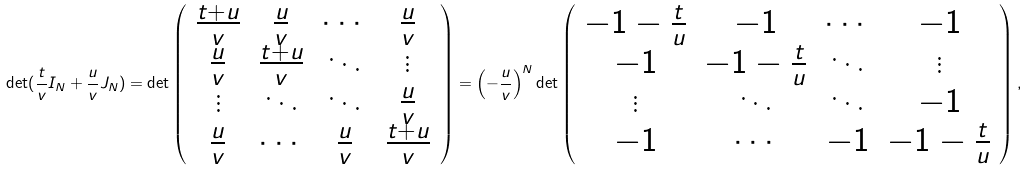Convert formula to latex. <formula><loc_0><loc_0><loc_500><loc_500>\det ( \frac { t } { v } { I } _ { N } + \frac { u } { v } { J } _ { N } ) = \det \left ( \begin{array} { c c c c } \frac { t + u } { v } & \frac { u } { v } & \cdots & \frac { u } { v } \\ \frac { u } { v } & \frac { t + u } { v } & \ddots & \vdots \\ \vdots & \ddots & \ddots & \frac { u } { v } \\ \frac { u } { v } & \cdots & \frac { u } { v } & \frac { t + u } { v } \\ \end{array} \right ) = \left ( - \frac { u } { v } \right ) ^ { N } \det \left ( \begin{array} { c c c c } - 1 - \frac { t } { u } & - 1 & \cdots & - 1 \\ - 1 & - 1 - \frac { t } { u } & \ddots & \vdots \\ \vdots & \ddots & \ddots & - 1 \\ - 1 & \cdots & - 1 & - 1 - \frac { t } { u } \\ \end{array} \right ) ,</formula> 